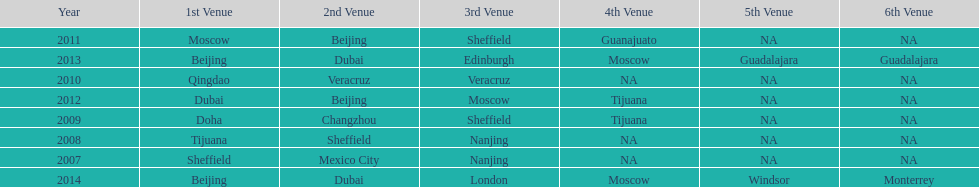Which is the only year that mexico is on a venue 2007. 